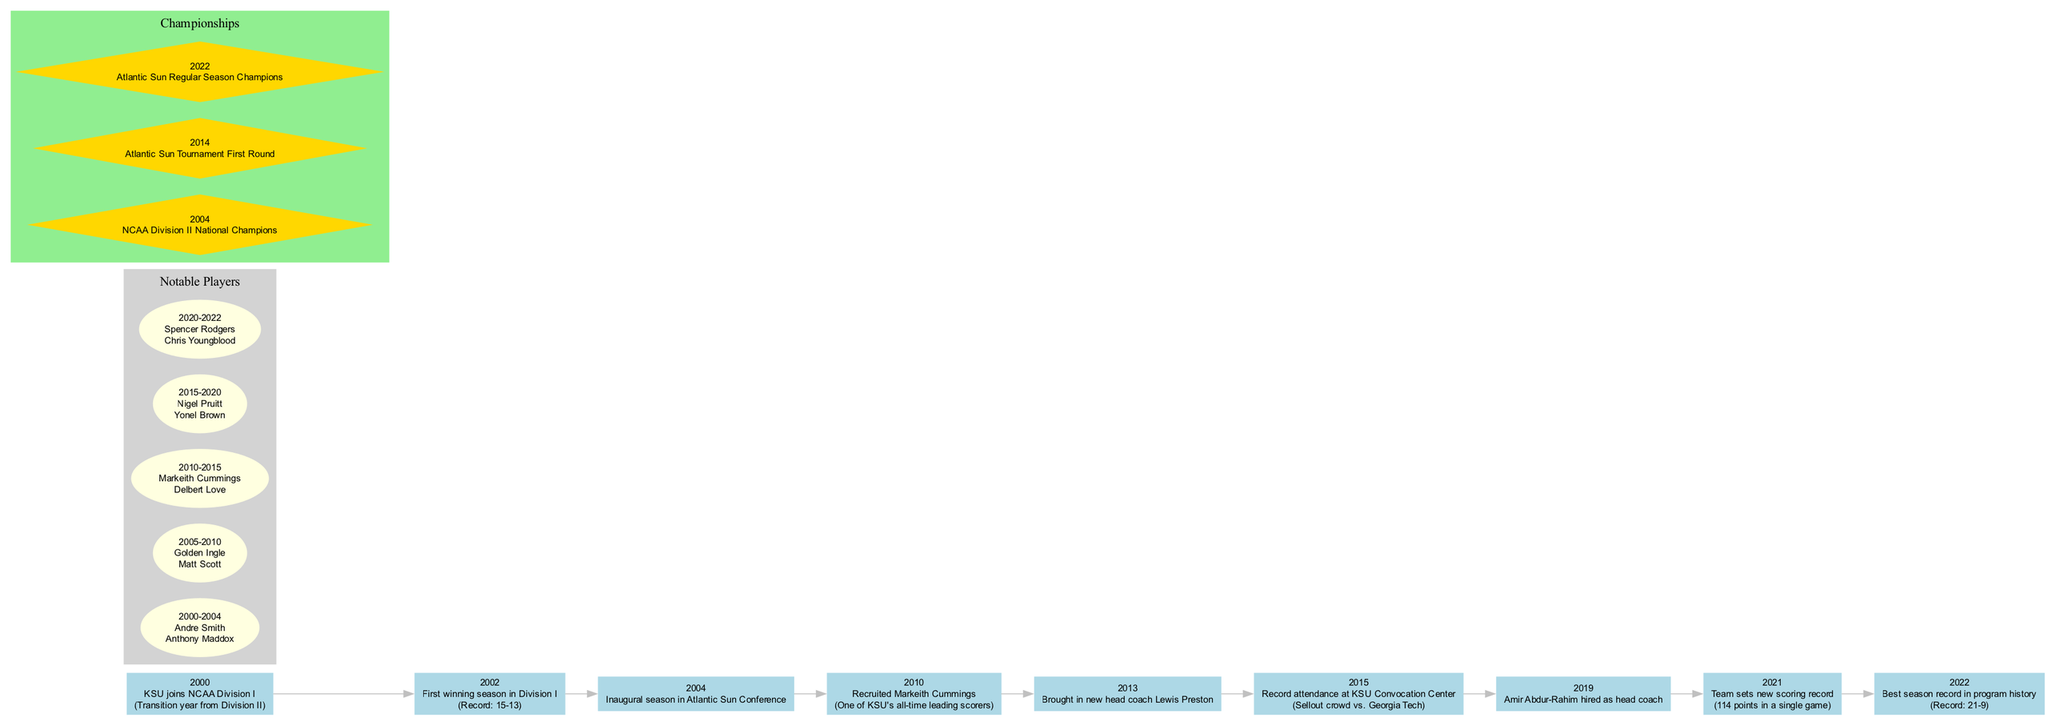What year did KSU join NCAA Division I? The diagram lists the milestone for the year 2000, which states that KSU joined NCAA Division I.
Answer: 2000 What was KSU's record during their first winning season in Division I? The timeline for the year 2002 shows the milestone "First winning season in Division I" with a record of 15-13.
Answer: 15-13 How many notable players are mentioned for the period 2010-2015? In the notable players section, the period 2010-2015 lists two players, Markeith Cummings and Delbert Love.
Answer: 2 What significant milestone occurred in 2022? The diagram highlights that in 2022, KSU achieved their best season record in program history with a 21-9 record.
Answer: Best season record in program history Which championship did KSU win in 2004? The championships section states that in 2004, KSU won the NCAA Division II National Championships.
Answer: NCAA Division II National Champions Who was hired as head coach in 2019? Looking at the timeline, it shows that Amir Abdur-Rahim was hired as head coach in 2019.
Answer: Amir Abdur-Rahim What is the color used for the notable players cluster? The diagram uses light gray for the background of the notable players cluster.
Answer: Light gray What connects the milestones of 2010 and 2015? The timeline indicates a sequential connection between the milestones of 2010 (recruiting Markeith Cummings) and 2015 (record attendance) through the edges connecting the years.
Answer: Edge between 2010 and 2015 What does the diamond shape represent in the diagram? The diamond shape is used in the championships cluster to signify the championships won by KSU in certain years.
Answer: Championships 